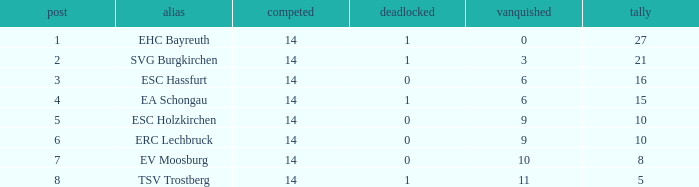What's the lost when there were more than 16 points and had a drawn less than 1? None. 